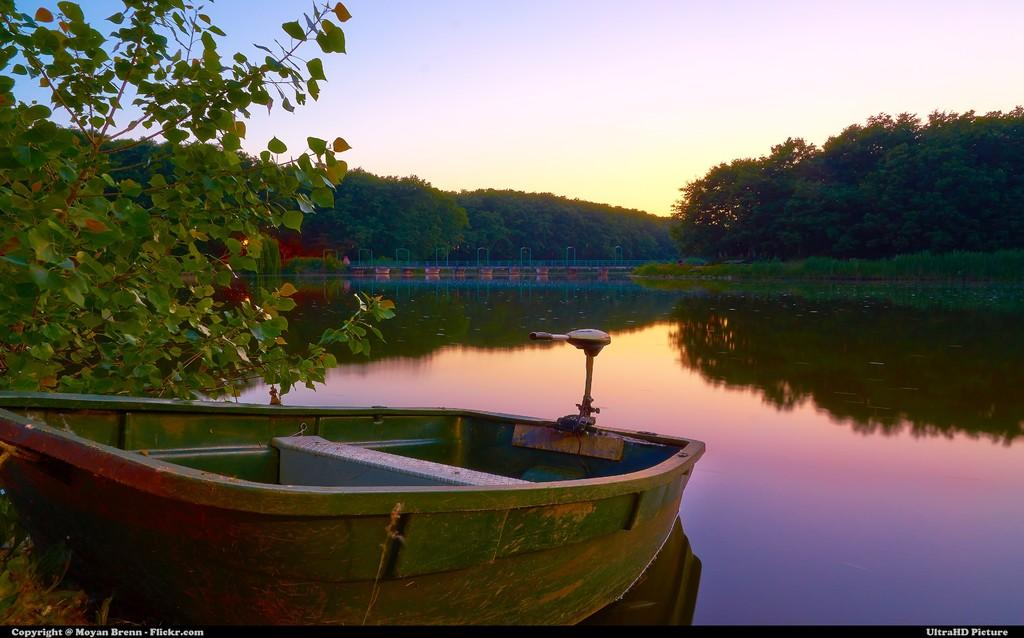What is the primary element in the image? There is water in the image. What is floating on the water? There is a boat in the image. What type of vegetation can be seen in the image? There is a plant in the image, and trees are visible in the background. Is there any text or marking on the image? Yes, there is a watermark at the bottom of the image. Where are the dogs sitting on the throne in the image? There are no dogs or thrones present in the image. What type of appliance can be seen in the image? There are no appliances visible in the image; it primarily features water, a boat, and vegetation. 